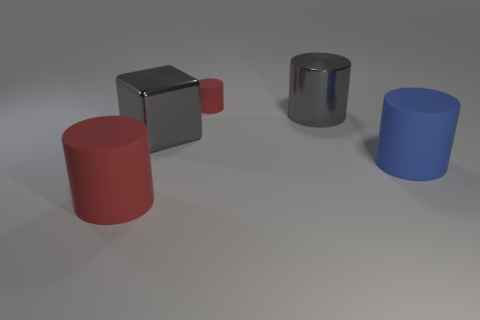There is another red matte thing that is the same shape as the large red matte thing; what is its size?
Your response must be concise. Small. What shape is the shiny thing to the left of the tiny object?
Give a very brief answer. Cube. The big matte thing that is on the right side of the rubber thing left of the gray cube is what color?
Your answer should be compact. Blue. How many objects are either cylinders that are in front of the blue thing or blue rubber cylinders?
Keep it short and to the point. 2. Does the gray shiny cylinder have the same size as the matte cylinder behind the large gray metal cube?
Give a very brief answer. No. What number of big objects are red cylinders or gray shiny cylinders?
Your answer should be very brief. 2. Is there a red object that has the same material as the tiny cylinder?
Your response must be concise. Yes. Are there more large blue cylinders than red matte things?
Your answer should be very brief. No. Is the big red cylinder made of the same material as the small red thing?
Provide a short and direct response. Yes. How many matte things are either large blue objects or small red cylinders?
Make the answer very short. 2. 